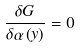Convert formula to latex. <formula><loc_0><loc_0><loc_500><loc_500>\frac { \delta G } { \delta \alpha \left ( y \right ) } = 0</formula> 